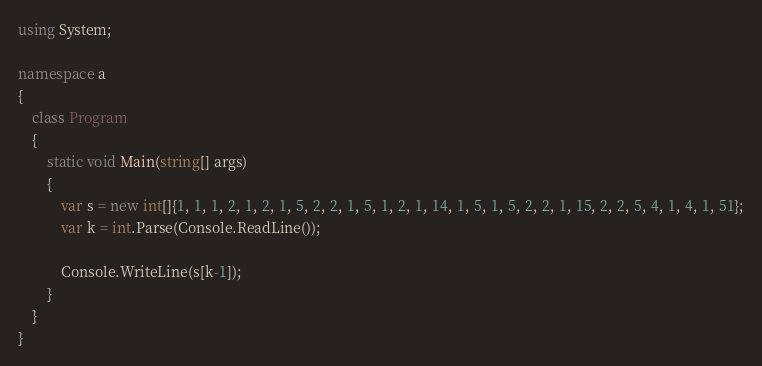Convert code to text. <code><loc_0><loc_0><loc_500><loc_500><_C#_>using System;

namespace a
{
    class Program
    {
        static void Main(string[] args)
        {
            var s = new int[]{1, 1, 1, 2, 1, 2, 1, 5, 2, 2, 1, 5, 1, 2, 1, 14, 1, 5, 1, 5, 2, 2, 1, 15, 2, 2, 5, 4, 1, 4, 1, 51};
            var k = int.Parse(Console.ReadLine());

            Console.WriteLine(s[k-1]);
        }
    }
}
</code> 